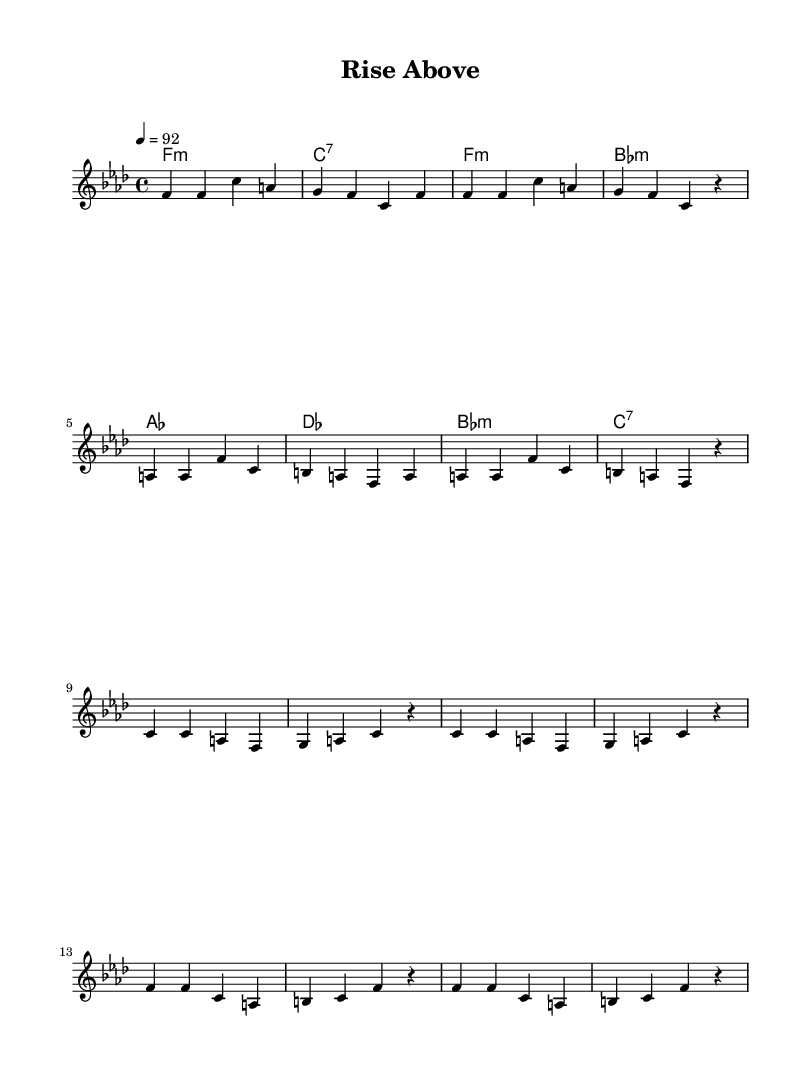What is the key signature of this music? The key signature is F minor, which has four flats (B♭, E♭, A♭, D♭). This is inferred from the presence of the F minor chord in the chord progressions shown in the music.
Answer: F minor What is the time signature of this music? The time signature is 4/4, which is indicated at the beginning of the score. It means there are four beats in each measure, and the quarter note gets one beat.
Answer: 4/4 What is the tempo marking for this music? The tempo marking is 92 beats per minute, which is specified before the melody section. This indicates how fast the music is meant to be played.
Answer: 92 How many measures are in the verse section? The verse section consists of 8 measures. Counting each set of bars within the verse part of the score confirms the total.
Answer: 8 What is the primary mood conveyed in the chorus based on typical rap themes? The primary mood is motivational. This is suggested by the repetition of uplifting phrases and the intent for personal growth and success in rap themes.
Answer: Motivational Which chord is played at the beginning of the verse? The initial chord in the verse is F minor. This is observed at the start of the chord progression in the music sheet.
Answer: F minor What type of musical phrases are utilized in rap songs like this one? The musical phrases are typically repetitive. This is common in motivational rap to imprint a message and create an engaging listening experience.
Answer: Repetitive 